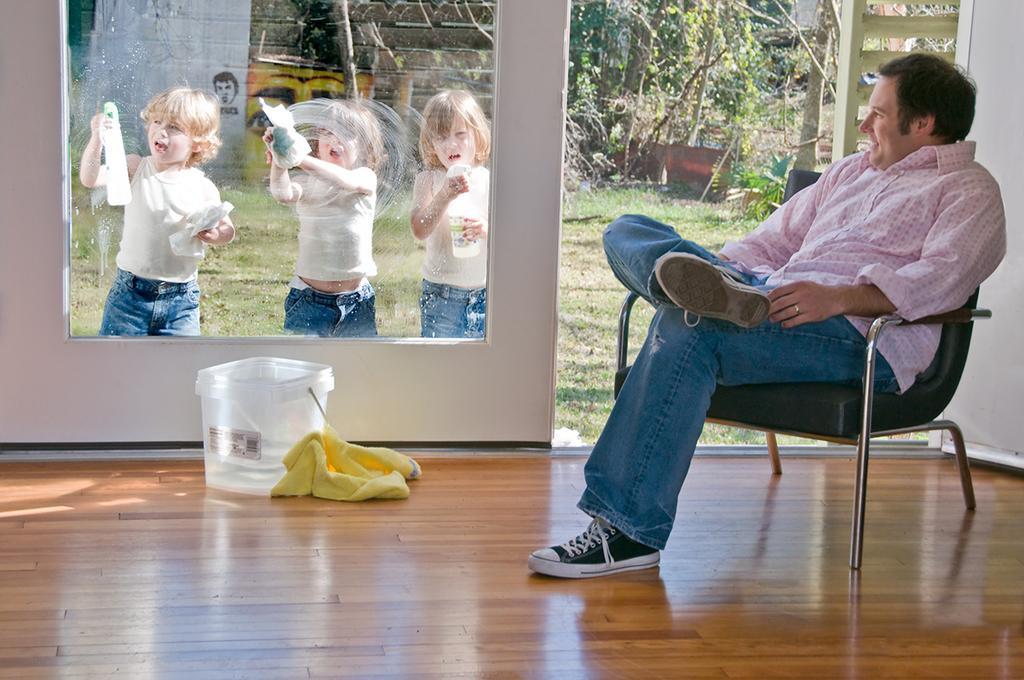Could you give a brief overview of what you see in this image? in this image i can see a person sitting on the right side of the room. behind him there are 3 people cleaning the glass. behind him there are many trees. 